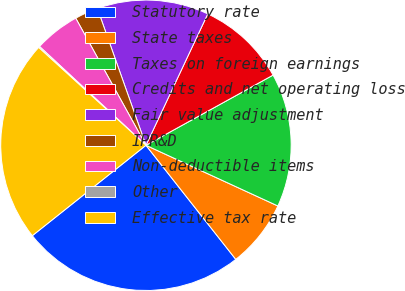Convert chart to OTSL. <chart><loc_0><loc_0><loc_500><loc_500><pie_chart><fcel>Statutory rate<fcel>State taxes<fcel>Taxes on foreign earnings<fcel>Credits and net operating loss<fcel>Fair value adjustment<fcel>IPR&D<fcel>Non-deductible items<fcel>Other<fcel>Effective tax rate<nl><fcel>24.92%<fcel>7.52%<fcel>14.89%<fcel>9.97%<fcel>12.43%<fcel>2.6%<fcel>5.06%<fcel>0.14%<fcel>22.46%<nl></chart> 